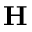<formula> <loc_0><loc_0><loc_500><loc_500>H</formula> 